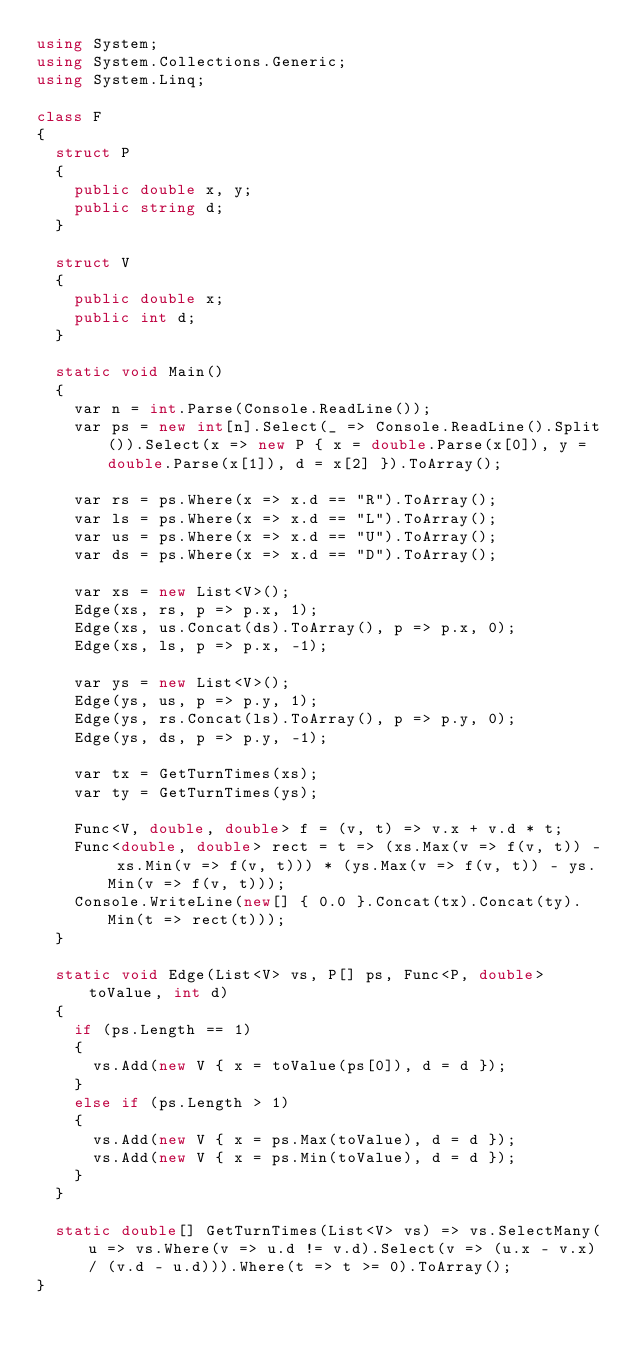<code> <loc_0><loc_0><loc_500><loc_500><_C#_>using System;
using System.Collections.Generic;
using System.Linq;

class F
{
	struct P
	{
		public double x, y;
		public string d;
	}

	struct V
	{
		public double x;
		public int d;
	}

	static void Main()
	{
		var n = int.Parse(Console.ReadLine());
		var ps = new int[n].Select(_ => Console.ReadLine().Split()).Select(x => new P { x = double.Parse(x[0]), y = double.Parse(x[1]), d = x[2] }).ToArray();

		var rs = ps.Where(x => x.d == "R").ToArray();
		var ls = ps.Where(x => x.d == "L").ToArray();
		var us = ps.Where(x => x.d == "U").ToArray();
		var ds = ps.Where(x => x.d == "D").ToArray();

		var xs = new List<V>();
		Edge(xs, rs, p => p.x, 1);
		Edge(xs, us.Concat(ds).ToArray(), p => p.x, 0);
		Edge(xs, ls, p => p.x, -1);

		var ys = new List<V>();
		Edge(ys, us, p => p.y, 1);
		Edge(ys, rs.Concat(ls).ToArray(), p => p.y, 0);
		Edge(ys, ds, p => p.y, -1);

		var tx = GetTurnTimes(xs);
		var ty = GetTurnTimes(ys);

		Func<V, double, double> f = (v, t) => v.x + v.d * t;
		Func<double, double> rect = t => (xs.Max(v => f(v, t)) - xs.Min(v => f(v, t))) * (ys.Max(v => f(v, t)) - ys.Min(v => f(v, t)));
		Console.WriteLine(new[] { 0.0 }.Concat(tx).Concat(ty).Min(t => rect(t)));
	}

	static void Edge(List<V> vs, P[] ps, Func<P, double> toValue, int d)
	{
		if (ps.Length == 1)
		{
			vs.Add(new V { x = toValue(ps[0]), d = d });
		}
		else if (ps.Length > 1)
		{
			vs.Add(new V { x = ps.Max(toValue), d = d });
			vs.Add(new V { x = ps.Min(toValue), d = d });
		}
	}

	static double[] GetTurnTimes(List<V> vs) => vs.SelectMany(u => vs.Where(v => u.d != v.d).Select(v => (u.x - v.x) / (v.d - u.d))).Where(t => t >= 0).ToArray();
}
</code> 